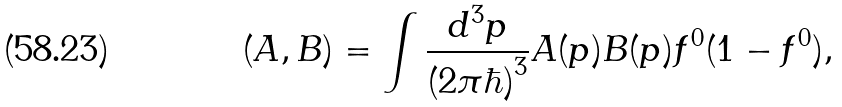Convert formula to latex. <formula><loc_0><loc_0><loc_500><loc_500>( A , B ) = \int \frac { d ^ { 3 } p } { ( 2 \pi \hbar { ) } ^ { 3 } } A ( { p } ) B ( { p } ) f ^ { 0 } ( 1 - f ^ { 0 } ) ,</formula> 